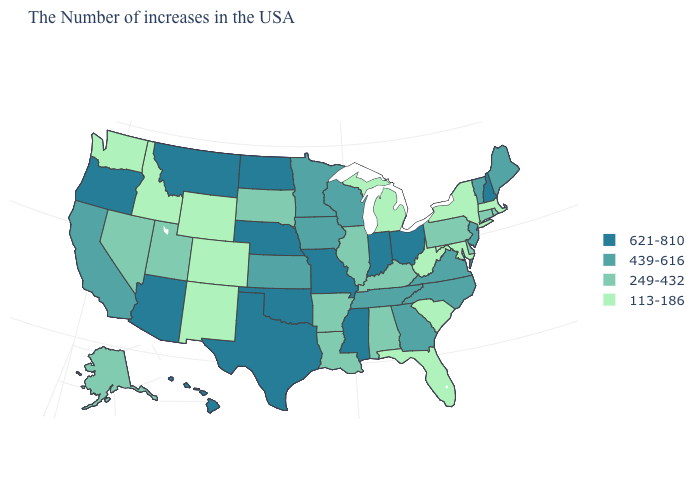Which states have the highest value in the USA?
Short answer required. New Hampshire, Ohio, Indiana, Mississippi, Missouri, Nebraska, Oklahoma, Texas, North Dakota, Montana, Arizona, Oregon, Hawaii. What is the value of Montana?
Give a very brief answer. 621-810. Is the legend a continuous bar?
Concise answer only. No. What is the value of Kentucky?
Be succinct. 249-432. Which states have the highest value in the USA?
Be succinct. New Hampshire, Ohio, Indiana, Mississippi, Missouri, Nebraska, Oklahoma, Texas, North Dakota, Montana, Arizona, Oregon, Hawaii. Name the states that have a value in the range 113-186?
Answer briefly. Massachusetts, New York, Maryland, South Carolina, West Virginia, Florida, Michigan, Wyoming, Colorado, New Mexico, Idaho, Washington. Does the map have missing data?
Write a very short answer. No. What is the value of Massachusetts?
Keep it brief. 113-186. What is the highest value in the USA?
Keep it brief. 621-810. Does Pennsylvania have the highest value in the Northeast?
Short answer required. No. How many symbols are there in the legend?
Be succinct. 4. Name the states that have a value in the range 249-432?
Answer briefly. Rhode Island, Connecticut, Delaware, Pennsylvania, Kentucky, Alabama, Illinois, Louisiana, Arkansas, South Dakota, Utah, Nevada, Alaska. What is the highest value in the West ?
Give a very brief answer. 621-810. What is the value of Kansas?
Quick response, please. 439-616. Name the states that have a value in the range 439-616?
Keep it brief. Maine, Vermont, New Jersey, Virginia, North Carolina, Georgia, Tennessee, Wisconsin, Minnesota, Iowa, Kansas, California. 